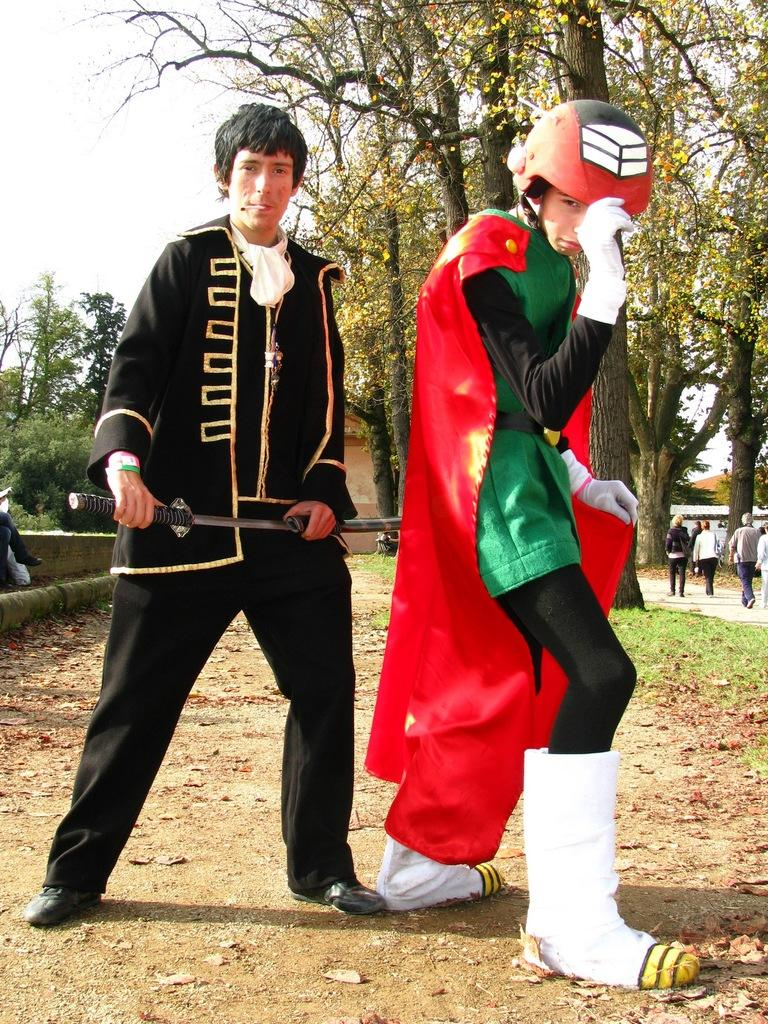What can be seen in the background of the image? There are trees and people walking in the background of the image. What are the people in the image wearing? The people in the image are wearing fancy dress. What are the people in fancy dress doing? The people in fancy dress are standing. What is the value of the throat in the image? There is no mention of a throat or any value associated with it in the image. 